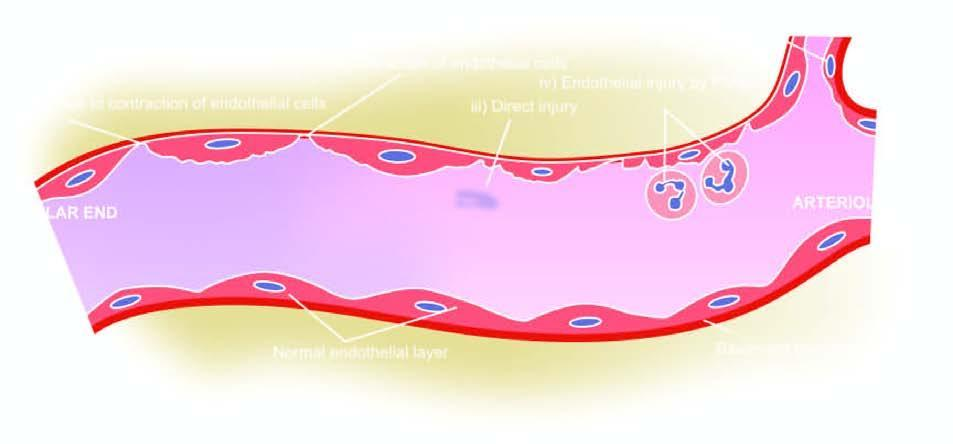do premitotic phases correspond to five numbers in the text?
Answer the question using a single word or phrase. No 